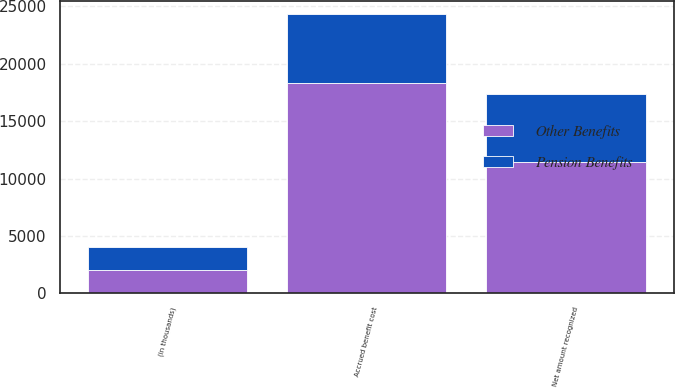Convert chart. <chart><loc_0><loc_0><loc_500><loc_500><stacked_bar_chart><ecel><fcel>(in thousands)<fcel>Accrued benefit cost<fcel>Net amount recognized<nl><fcel>Other Benefits<fcel>2004<fcel>18345<fcel>11429<nl><fcel>Pension Benefits<fcel>2004<fcel>5950<fcel>5950<nl></chart> 